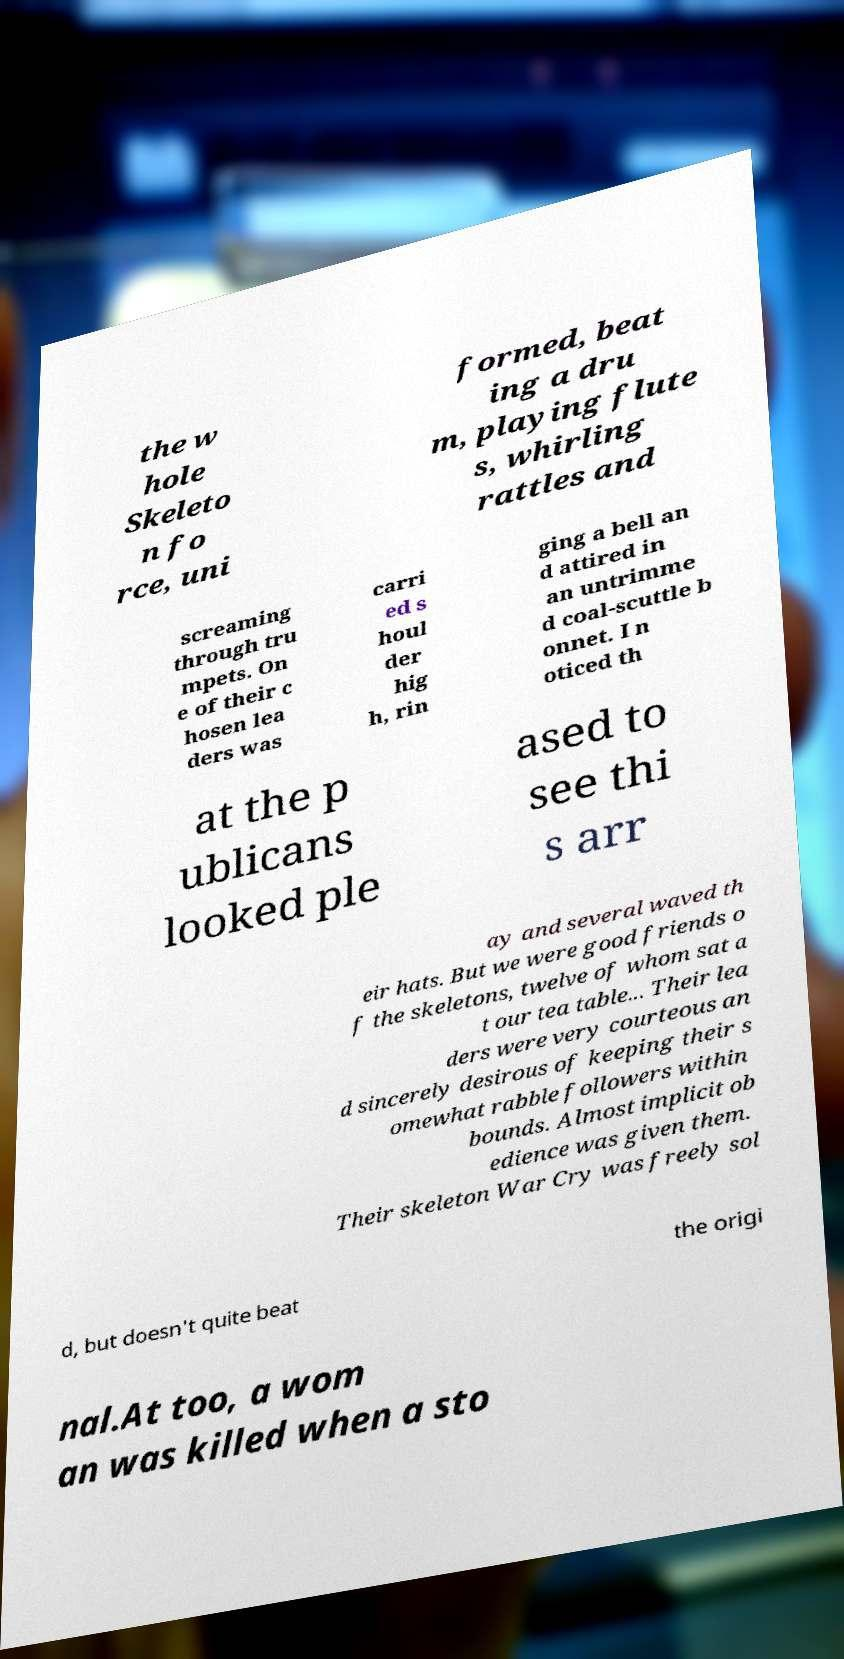Can you read and provide the text displayed in the image?This photo seems to have some interesting text. Can you extract and type it out for me? the w hole Skeleto n fo rce, uni formed, beat ing a dru m, playing flute s, whirling rattles and screaming through tru mpets. On e of their c hosen lea ders was carri ed s houl der hig h, rin ging a bell an d attired in an untrimme d coal-scuttle b onnet. I n oticed th at the p ublicans looked ple ased to see thi s arr ay and several waved th eir hats. But we were good friends o f the skeletons, twelve of whom sat a t our tea table... Their lea ders were very courteous an d sincerely desirous of keeping their s omewhat rabble followers within bounds. Almost implicit ob edience was given them. Their skeleton War Cry was freely sol d, but doesn't quite beat the origi nal.At too, a wom an was killed when a sto 